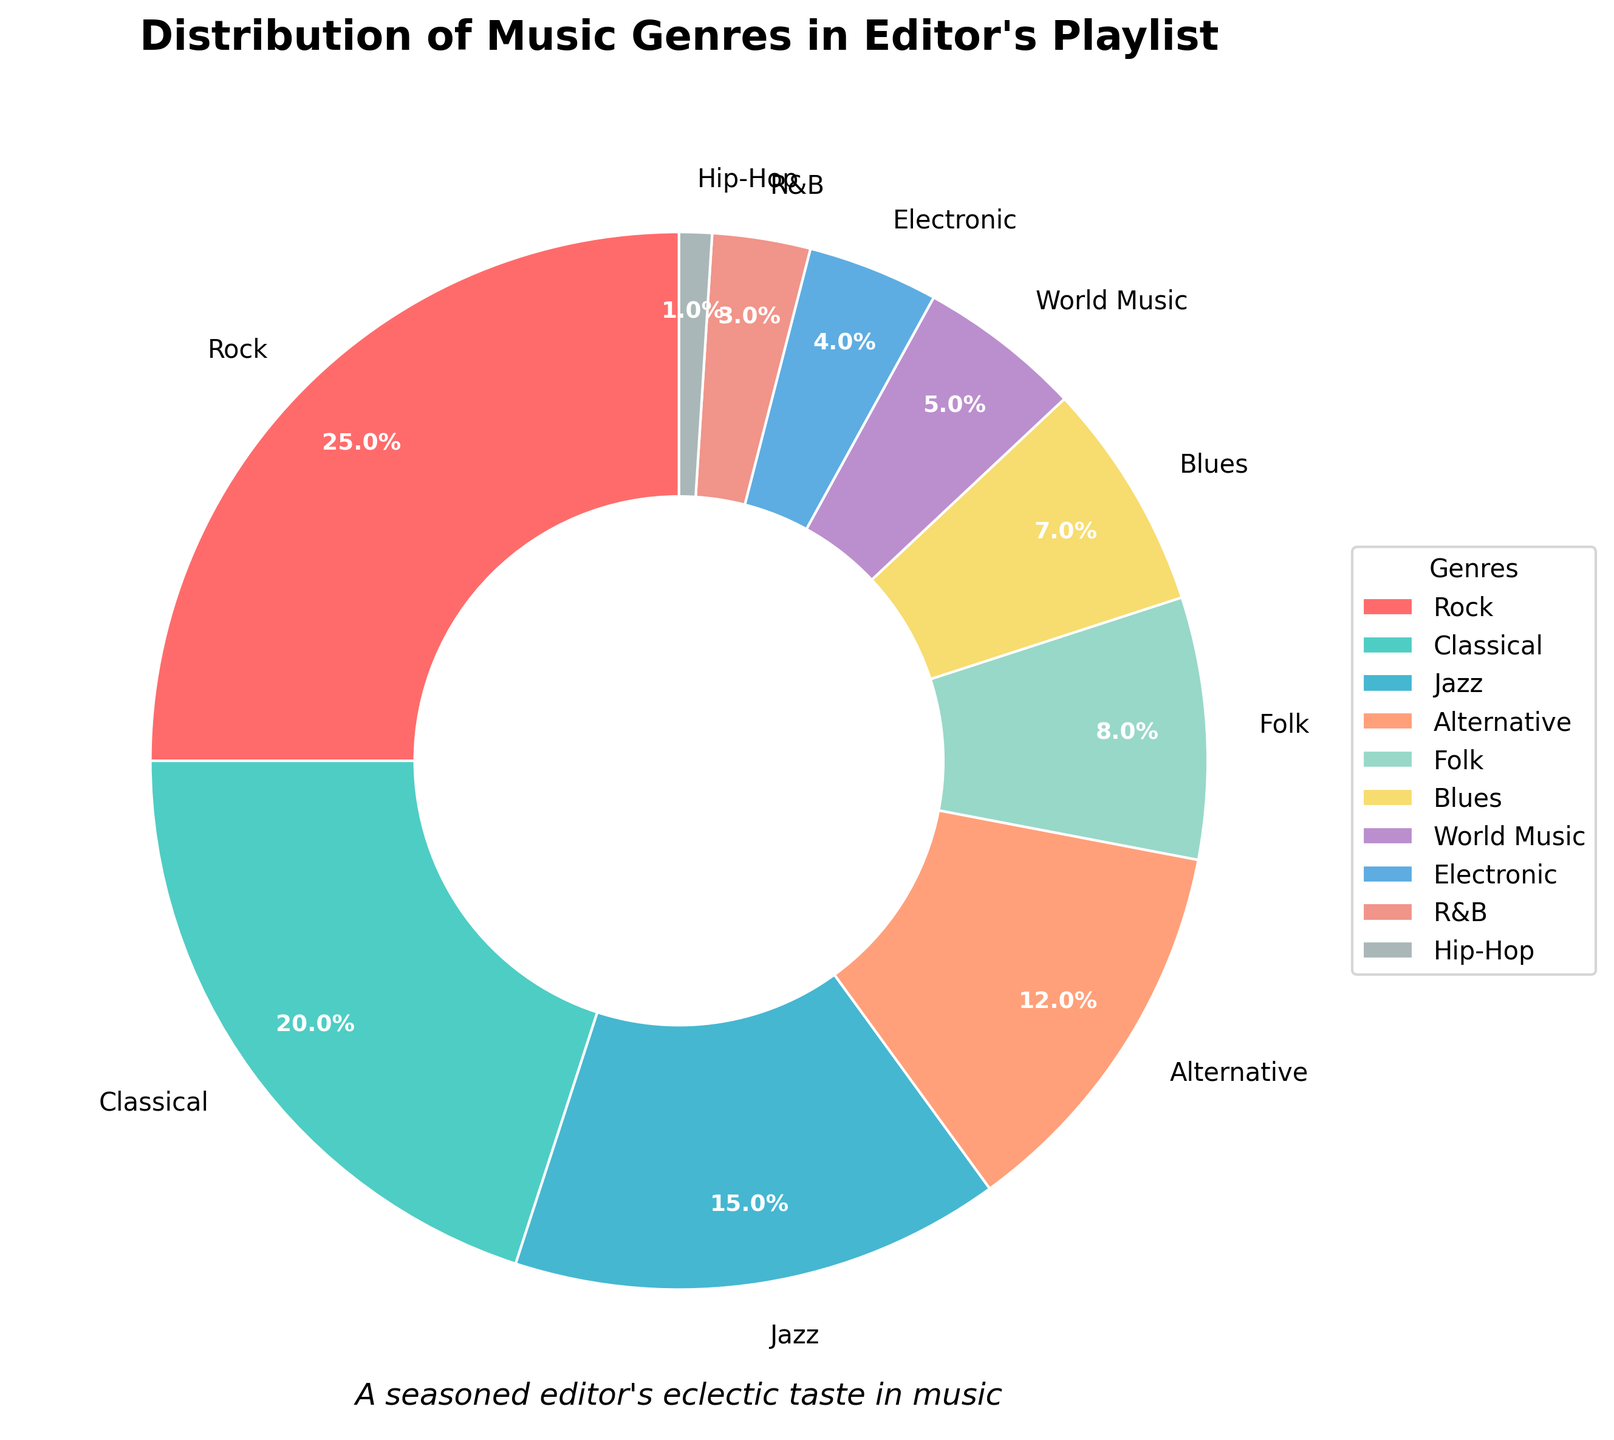What percentage of the playlist is made up of genres other than Rock? To find the percentage of genres other than Rock, subtract the percentage for Rock from 100%. The percentage for Rock is 25%, so the calculation is 100% - 25% = 75%.
Answer: 75% Which genre has a higher representation in the playlist, Jazz or Blues? Compare the percentages of Jazz and Blues. Jazz has 15%, and Blues has 7%, so Jazz has a higher representation.
Answer: Jazz How does the combined percentage of Classical and Alternative music compare to that of Rock? Sum the percentages of Classical and Alternative and compare it to Rock. Classical is 20%, Alternative is 12%, and their combined percentage is 20% + 12% = 32%. Rock is 25%. Therefore, the combined percentage of Classical and Alternative is higher than Rock.
Answer: The combined percentage is higher What is the difference in percentage between Folk and R&B? Subtract the percentage of R&B from Folk. Folk is 8% and R&B is 3%. The difference is 8% - 3% = 5%.
Answer: 5% Which genre is represented by a green color in the pie chart? The pie chart uses a custom color palette, and the second color (green) in the provided palette corresponds to Classical.
Answer: Classical What is the percentage sum of the three least represented genres? Identify the three genres with the smallest percentages: Hip-Hop (1%), R&B (3%), and Electronic (4%). Sum these percentages: 1% + 3% + 4% = 8%.
Answer: 8% Which genre has the closest percentage to the average percentage across all genres? First, calculate the average percentage. The total percentage across all genres is 100%, and there are 10 genres. The average is 100% / 10 = 10%. The genres and their percentages are as follows: Rock (25%), Classical (20%), Jazz (15%), Alternative (12%), Folk (8%), Blues (7%), World Music (5%), Electronic (4%), R&B (3%), and Hip-Hop (1%). The genre with the closest percentage to 10% is Alternative with 12%.
Answer: Alternative What percentage of the playlist consists of genres with at least 10% representation? Identify the genres with at least 10%: Rock (25%), Classical (20%), Jazz (15%), and Alternative (12%). Sum these percentages: 25% + 20% + 15% + 12% = 72%.
Answer: 72% Which genre segment appears the smallest in the pie chart? The genre with the smallest percentage is Hip-Hop, which has 1%.
Answer: Hip-Hop What is the combined percentage of genres with less than 5% representation? Identify genres with less than 5%: R&B (3%) and Hip-Hop (1%). Sum these percentages: 3% + 1% = 4%.
Answer: 4% 